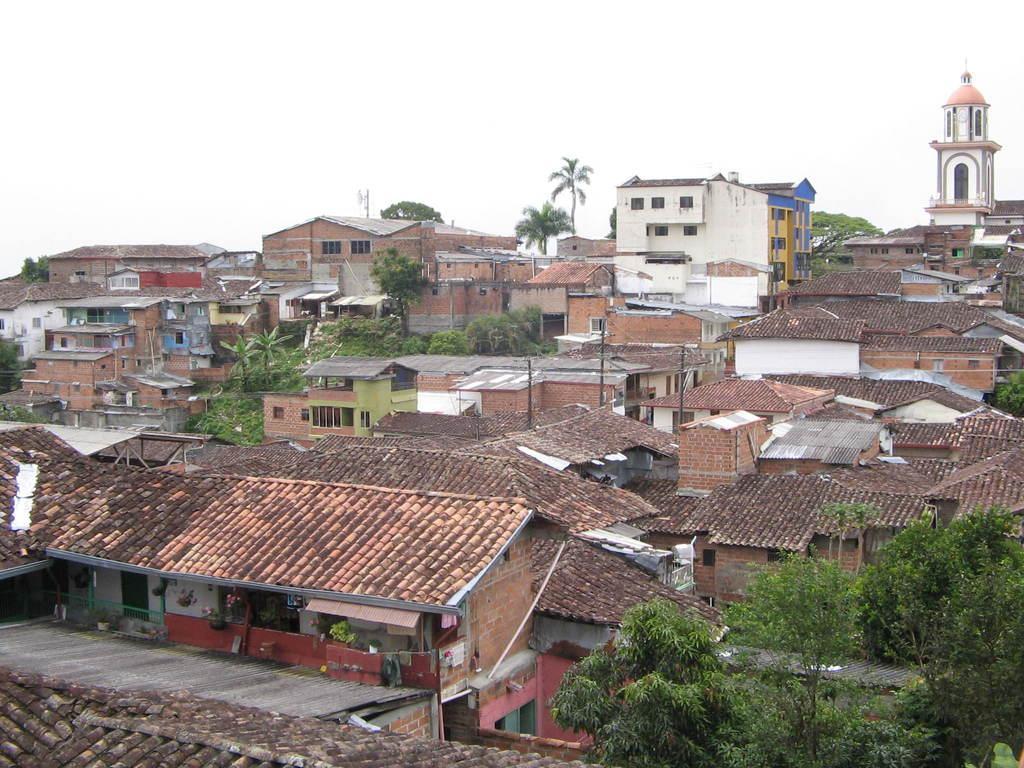How would you summarize this image in a sentence or two? This picture is clicked outside. On the right corner we can see the trees. In the center we can see the houses with the red rooftops. In the background there is a sky, tower, trees, buildings and houses. 